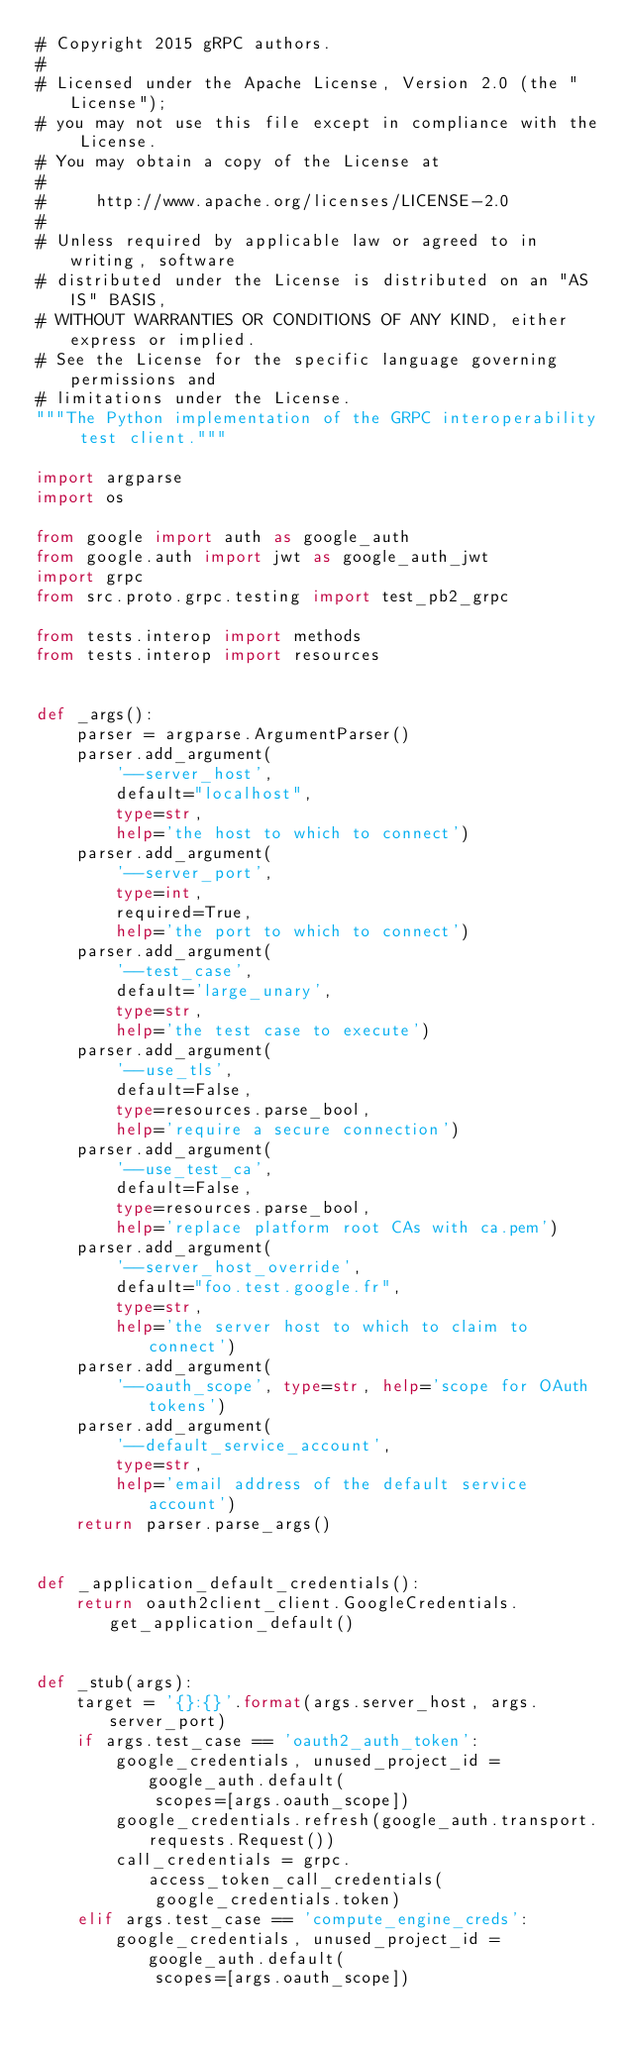Convert code to text. <code><loc_0><loc_0><loc_500><loc_500><_Python_># Copyright 2015 gRPC authors.
#
# Licensed under the Apache License, Version 2.0 (the "License");
# you may not use this file except in compliance with the License.
# You may obtain a copy of the License at
#
#     http://www.apache.org/licenses/LICENSE-2.0
#
# Unless required by applicable law or agreed to in writing, software
# distributed under the License is distributed on an "AS IS" BASIS,
# WITHOUT WARRANTIES OR CONDITIONS OF ANY KIND, either express or implied.
# See the License for the specific language governing permissions and
# limitations under the License.
"""The Python implementation of the GRPC interoperability test client."""

import argparse
import os

from google import auth as google_auth
from google.auth import jwt as google_auth_jwt
import grpc
from src.proto.grpc.testing import test_pb2_grpc

from tests.interop import methods
from tests.interop import resources


def _args():
    parser = argparse.ArgumentParser()
    parser.add_argument(
        '--server_host',
        default="localhost",
        type=str,
        help='the host to which to connect')
    parser.add_argument(
        '--server_port',
        type=int,
        required=True,
        help='the port to which to connect')
    parser.add_argument(
        '--test_case',
        default='large_unary',
        type=str,
        help='the test case to execute')
    parser.add_argument(
        '--use_tls',
        default=False,
        type=resources.parse_bool,
        help='require a secure connection')
    parser.add_argument(
        '--use_test_ca',
        default=False,
        type=resources.parse_bool,
        help='replace platform root CAs with ca.pem')
    parser.add_argument(
        '--server_host_override',
        default="foo.test.google.fr",
        type=str,
        help='the server host to which to claim to connect')
    parser.add_argument(
        '--oauth_scope', type=str, help='scope for OAuth tokens')
    parser.add_argument(
        '--default_service_account',
        type=str,
        help='email address of the default service account')
    return parser.parse_args()


def _application_default_credentials():
    return oauth2client_client.GoogleCredentials.get_application_default()


def _stub(args):
    target = '{}:{}'.format(args.server_host, args.server_port)
    if args.test_case == 'oauth2_auth_token':
        google_credentials, unused_project_id = google_auth.default(
            scopes=[args.oauth_scope])
        google_credentials.refresh(google_auth.transport.requests.Request())
        call_credentials = grpc.access_token_call_credentials(
            google_credentials.token)
    elif args.test_case == 'compute_engine_creds':
        google_credentials, unused_project_id = google_auth.default(
            scopes=[args.oauth_scope])</code> 